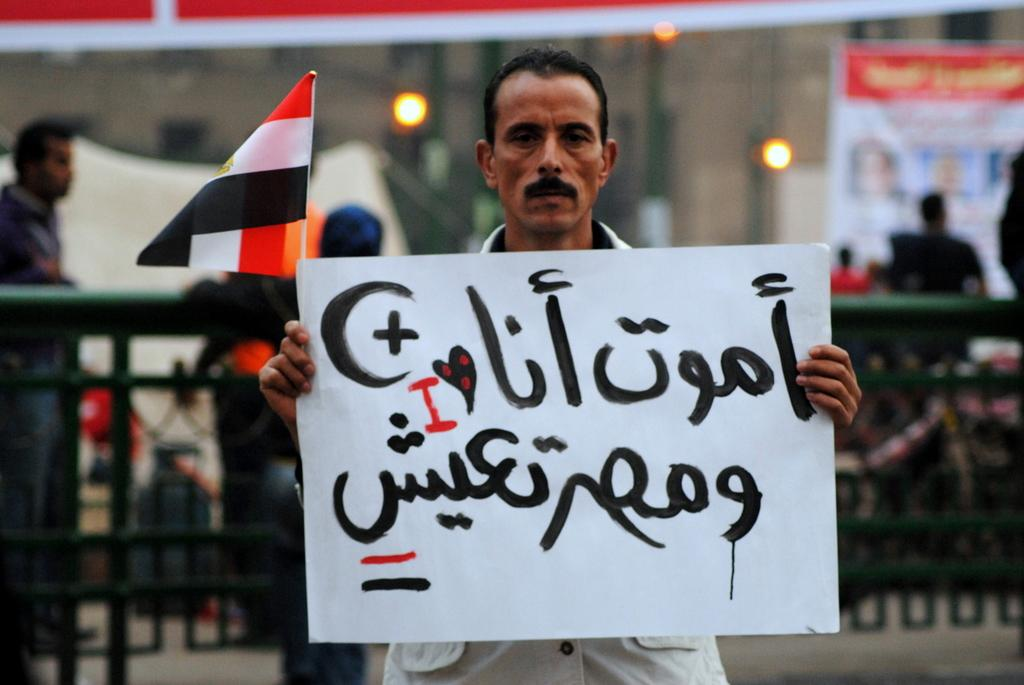Who is the main subject in the image? There is a man in the middle of the image. What is the man holding in the image? The man is holding a white color chart. Can you describe the color chart? The chart has some text on it. What can be seen in the background of the image? There are people and a railing in the background of the image. What type of science experiment is the man conducting in the image? There is no indication of a science experiment in the image; the man is simply holding a white color chart. How many mouths and necks can be seen in the image? There are no mouths or necks visible in the image. 